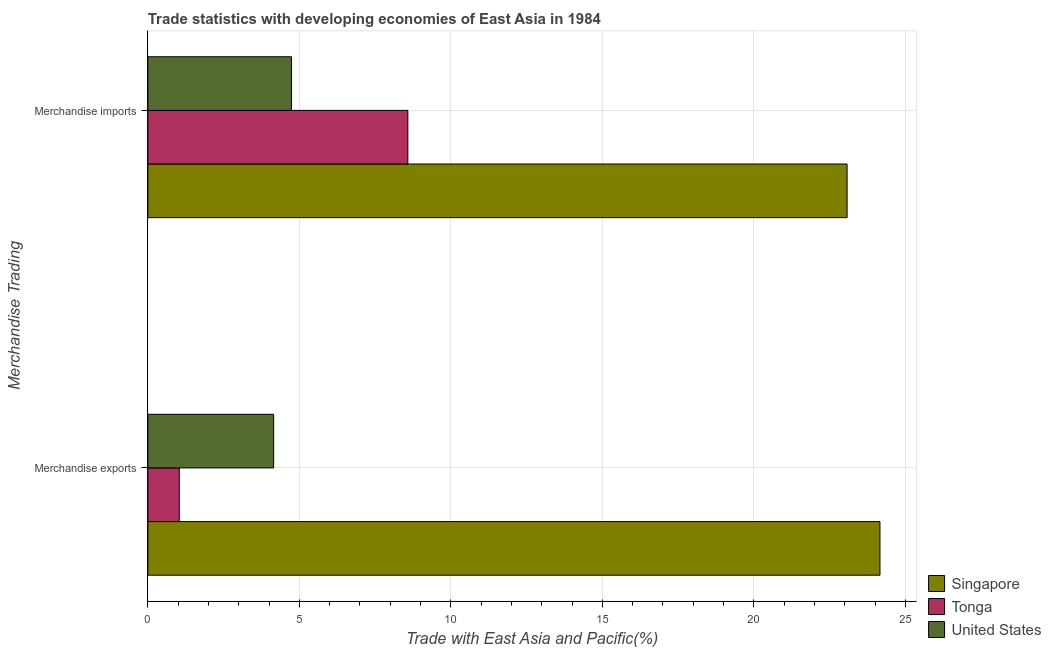Are the number of bars per tick equal to the number of legend labels?
Provide a succinct answer. Yes. Are the number of bars on each tick of the Y-axis equal?
Your answer should be compact. Yes. What is the label of the 2nd group of bars from the top?
Keep it short and to the point. Merchandise exports. What is the merchandise imports in Singapore?
Offer a very short reply. 23.08. Across all countries, what is the maximum merchandise exports?
Give a very brief answer. 24.16. Across all countries, what is the minimum merchandise exports?
Your response must be concise. 1.04. In which country was the merchandise exports maximum?
Provide a short and direct response. Singapore. In which country was the merchandise exports minimum?
Offer a very short reply. Tonga. What is the total merchandise exports in the graph?
Make the answer very short. 29.35. What is the difference between the merchandise imports in Tonga and that in Singapore?
Provide a short and direct response. -14.5. What is the difference between the merchandise exports in United States and the merchandise imports in Singapore?
Keep it short and to the point. -18.93. What is the average merchandise imports per country?
Provide a succinct answer. 12.13. What is the difference between the merchandise exports and merchandise imports in Singapore?
Give a very brief answer. 1.08. What is the ratio of the merchandise exports in Singapore to that in United States?
Make the answer very short. 5.82. In how many countries, is the merchandise exports greater than the average merchandise exports taken over all countries?
Offer a terse response. 1. What does the 1st bar from the bottom in Merchandise imports represents?
Ensure brevity in your answer.  Singapore. Are all the bars in the graph horizontal?
Give a very brief answer. Yes. How many countries are there in the graph?
Your answer should be very brief. 3. Does the graph contain any zero values?
Ensure brevity in your answer.  No. Does the graph contain grids?
Provide a succinct answer. Yes. Where does the legend appear in the graph?
Keep it short and to the point. Bottom right. How many legend labels are there?
Ensure brevity in your answer.  3. What is the title of the graph?
Your response must be concise. Trade statistics with developing economies of East Asia in 1984. What is the label or title of the X-axis?
Offer a very short reply. Trade with East Asia and Pacific(%). What is the label or title of the Y-axis?
Your answer should be compact. Merchandise Trading. What is the Trade with East Asia and Pacific(%) of Singapore in Merchandise exports?
Give a very brief answer. 24.16. What is the Trade with East Asia and Pacific(%) of Tonga in Merchandise exports?
Your response must be concise. 1.04. What is the Trade with East Asia and Pacific(%) of United States in Merchandise exports?
Your response must be concise. 4.15. What is the Trade with East Asia and Pacific(%) of Singapore in Merchandise imports?
Your answer should be compact. 23.08. What is the Trade with East Asia and Pacific(%) in Tonga in Merchandise imports?
Make the answer very short. 8.58. What is the Trade with East Asia and Pacific(%) in United States in Merchandise imports?
Your response must be concise. 4.74. Across all Merchandise Trading, what is the maximum Trade with East Asia and Pacific(%) in Singapore?
Give a very brief answer. 24.16. Across all Merchandise Trading, what is the maximum Trade with East Asia and Pacific(%) of Tonga?
Ensure brevity in your answer.  8.58. Across all Merchandise Trading, what is the maximum Trade with East Asia and Pacific(%) of United States?
Your response must be concise. 4.74. Across all Merchandise Trading, what is the minimum Trade with East Asia and Pacific(%) in Singapore?
Provide a succinct answer. 23.08. Across all Merchandise Trading, what is the minimum Trade with East Asia and Pacific(%) in Tonga?
Offer a very short reply. 1.04. Across all Merchandise Trading, what is the minimum Trade with East Asia and Pacific(%) of United States?
Ensure brevity in your answer.  4.15. What is the total Trade with East Asia and Pacific(%) in Singapore in the graph?
Offer a terse response. 47.24. What is the total Trade with East Asia and Pacific(%) in Tonga in the graph?
Ensure brevity in your answer.  9.62. What is the total Trade with East Asia and Pacific(%) of United States in the graph?
Your answer should be very brief. 8.89. What is the difference between the Trade with East Asia and Pacific(%) in Singapore in Merchandise exports and that in Merchandise imports?
Your response must be concise. 1.08. What is the difference between the Trade with East Asia and Pacific(%) of Tonga in Merchandise exports and that in Merchandise imports?
Your answer should be very brief. -7.54. What is the difference between the Trade with East Asia and Pacific(%) in United States in Merchandise exports and that in Merchandise imports?
Provide a short and direct response. -0.59. What is the difference between the Trade with East Asia and Pacific(%) in Singapore in Merchandise exports and the Trade with East Asia and Pacific(%) in Tonga in Merchandise imports?
Provide a succinct answer. 15.58. What is the difference between the Trade with East Asia and Pacific(%) in Singapore in Merchandise exports and the Trade with East Asia and Pacific(%) in United States in Merchandise imports?
Offer a terse response. 19.42. What is the difference between the Trade with East Asia and Pacific(%) in Tonga in Merchandise exports and the Trade with East Asia and Pacific(%) in United States in Merchandise imports?
Give a very brief answer. -3.7. What is the average Trade with East Asia and Pacific(%) in Singapore per Merchandise Trading?
Offer a terse response. 23.62. What is the average Trade with East Asia and Pacific(%) in Tonga per Merchandise Trading?
Offer a very short reply. 4.81. What is the average Trade with East Asia and Pacific(%) of United States per Merchandise Trading?
Give a very brief answer. 4.45. What is the difference between the Trade with East Asia and Pacific(%) of Singapore and Trade with East Asia and Pacific(%) of Tonga in Merchandise exports?
Provide a succinct answer. 23.12. What is the difference between the Trade with East Asia and Pacific(%) of Singapore and Trade with East Asia and Pacific(%) of United States in Merchandise exports?
Give a very brief answer. 20.01. What is the difference between the Trade with East Asia and Pacific(%) of Tonga and Trade with East Asia and Pacific(%) of United States in Merchandise exports?
Ensure brevity in your answer.  -3.11. What is the difference between the Trade with East Asia and Pacific(%) in Singapore and Trade with East Asia and Pacific(%) in Tonga in Merchandise imports?
Provide a short and direct response. 14.5. What is the difference between the Trade with East Asia and Pacific(%) of Singapore and Trade with East Asia and Pacific(%) of United States in Merchandise imports?
Make the answer very short. 18.34. What is the difference between the Trade with East Asia and Pacific(%) of Tonga and Trade with East Asia and Pacific(%) of United States in Merchandise imports?
Provide a succinct answer. 3.84. What is the ratio of the Trade with East Asia and Pacific(%) in Singapore in Merchandise exports to that in Merchandise imports?
Offer a terse response. 1.05. What is the ratio of the Trade with East Asia and Pacific(%) of Tonga in Merchandise exports to that in Merchandise imports?
Give a very brief answer. 0.12. What is the ratio of the Trade with East Asia and Pacific(%) in United States in Merchandise exports to that in Merchandise imports?
Give a very brief answer. 0.88. What is the difference between the highest and the second highest Trade with East Asia and Pacific(%) of Singapore?
Make the answer very short. 1.08. What is the difference between the highest and the second highest Trade with East Asia and Pacific(%) in Tonga?
Keep it short and to the point. 7.54. What is the difference between the highest and the second highest Trade with East Asia and Pacific(%) of United States?
Your answer should be very brief. 0.59. What is the difference between the highest and the lowest Trade with East Asia and Pacific(%) of Singapore?
Provide a succinct answer. 1.08. What is the difference between the highest and the lowest Trade with East Asia and Pacific(%) in Tonga?
Provide a succinct answer. 7.54. What is the difference between the highest and the lowest Trade with East Asia and Pacific(%) in United States?
Offer a very short reply. 0.59. 